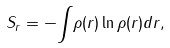<formula> <loc_0><loc_0><loc_500><loc_500>S _ { r } = - { \int } { \rho } ( { r } ) \ln { \rho } ( { r } ) d { r } ,</formula> 